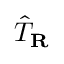Convert formula to latex. <formula><loc_0><loc_0><loc_500><loc_500>{ \hat { T } } _ { R }</formula> 